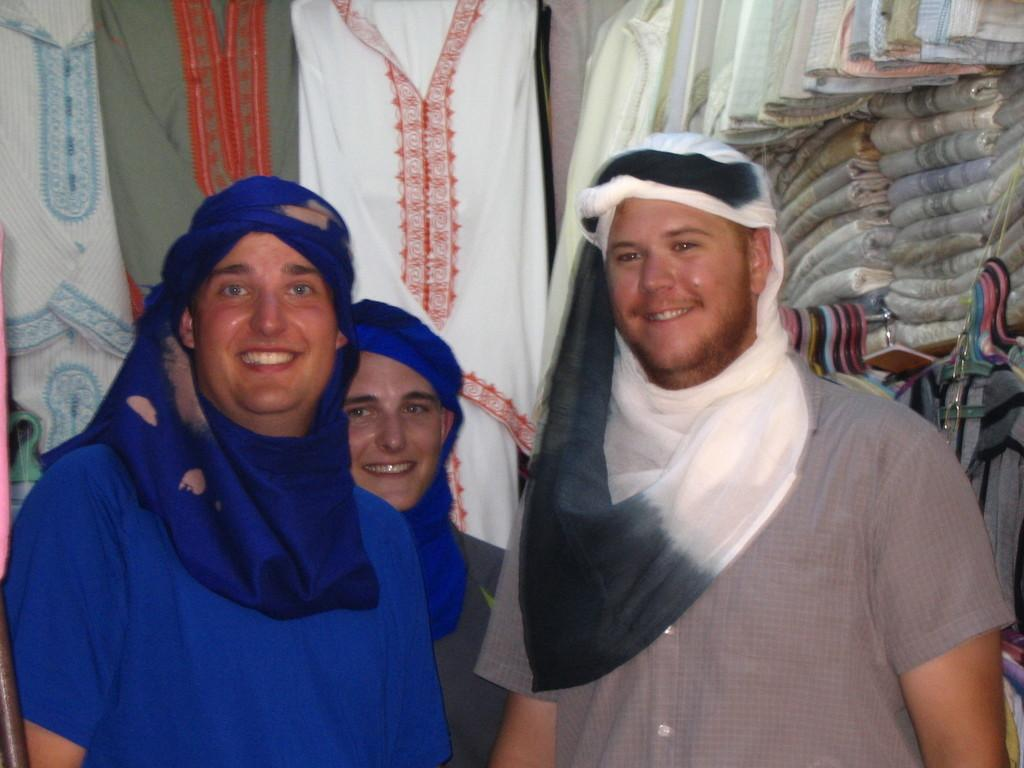How many men are in the image? There are three men in the image. What are the men doing in the image? The men are standing and smiling. What can be seen in the background of the image? There are clothes hanged on a hanger in the background. What is located on the right side of the image? There are clothes placed in a rack on the right side of the image. Can you see any bees buzzing around the men in the image? No, there are no bees present in the image. Are there any fairies flying around the clothes rack in the image? No, there are no fairies present in the image. 